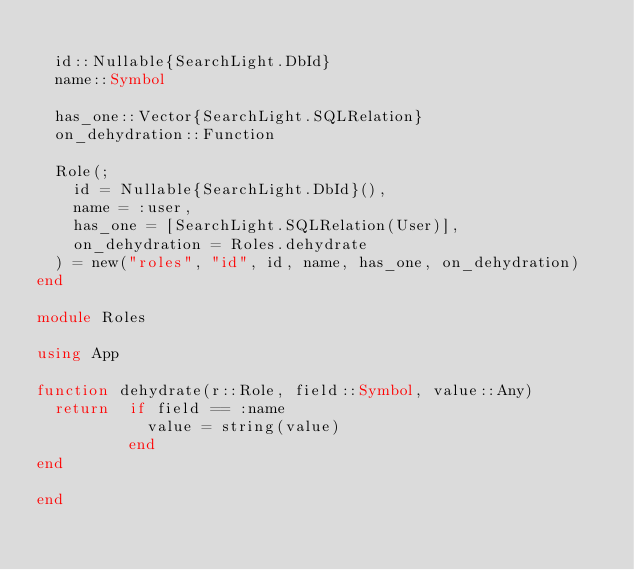<code> <loc_0><loc_0><loc_500><loc_500><_Julia_>
  id::Nullable{SearchLight.DbId}
  name::Symbol

  has_one::Vector{SearchLight.SQLRelation}
  on_dehydration::Function

  Role(;
    id = Nullable{SearchLight.DbId}(),
    name = :user,
    has_one = [SearchLight.SQLRelation(User)],
    on_dehydration = Roles.dehydrate
  ) = new("roles", "id", id, name, has_one, on_dehydration)
end

module Roles

using App

function dehydrate(r::Role, field::Symbol, value::Any)
  return  if field == :name
            value = string(value)
          end
end

end
</code> 